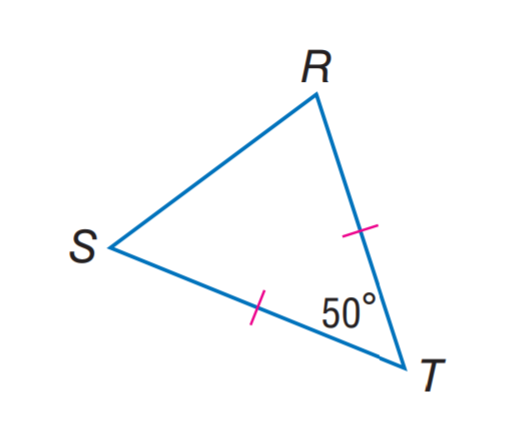Answer the mathemtical geometry problem and directly provide the correct option letter.
Question: Find m \angle S R T.
Choices: A: 50 B: 55 C: 60 D: 65 D 